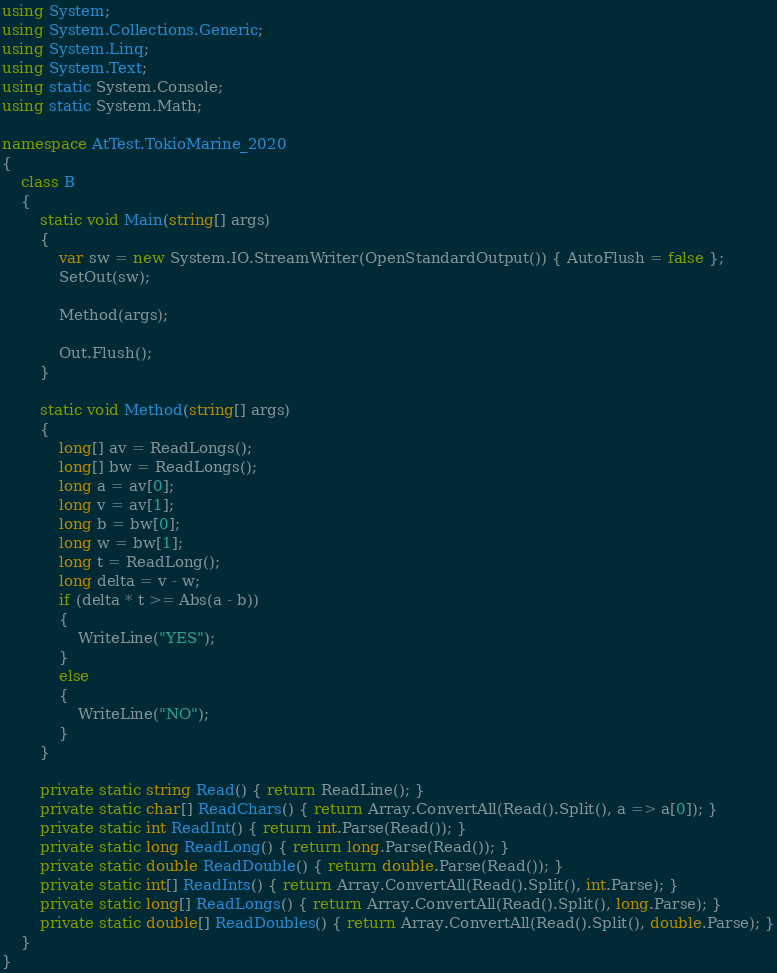Convert code to text. <code><loc_0><loc_0><loc_500><loc_500><_C#_>using System;
using System.Collections.Generic;
using System.Linq;
using System.Text;
using static System.Console;
using static System.Math;

namespace AtTest.TokioMarine_2020
{
    class B
    {
        static void Main(string[] args)
        {
            var sw = new System.IO.StreamWriter(OpenStandardOutput()) { AutoFlush = false };
            SetOut(sw);

            Method(args);

            Out.Flush();
        }

        static void Method(string[] args)
        {
            long[] av = ReadLongs();
            long[] bw = ReadLongs();
            long a = av[0];
            long v = av[1];
            long b = bw[0];
            long w = bw[1];
            long t = ReadLong();
            long delta = v - w;
            if (delta * t >= Abs(a - b))
            {
                WriteLine("YES");
            }
            else
            {
                WriteLine("NO");
            }
        }

        private static string Read() { return ReadLine(); }
        private static char[] ReadChars() { return Array.ConvertAll(Read().Split(), a => a[0]); }
        private static int ReadInt() { return int.Parse(Read()); }
        private static long ReadLong() { return long.Parse(Read()); }
        private static double ReadDouble() { return double.Parse(Read()); }
        private static int[] ReadInts() { return Array.ConvertAll(Read().Split(), int.Parse); }
        private static long[] ReadLongs() { return Array.ConvertAll(Read().Split(), long.Parse); }
        private static double[] ReadDoubles() { return Array.ConvertAll(Read().Split(), double.Parse); }
    }
}
</code> 